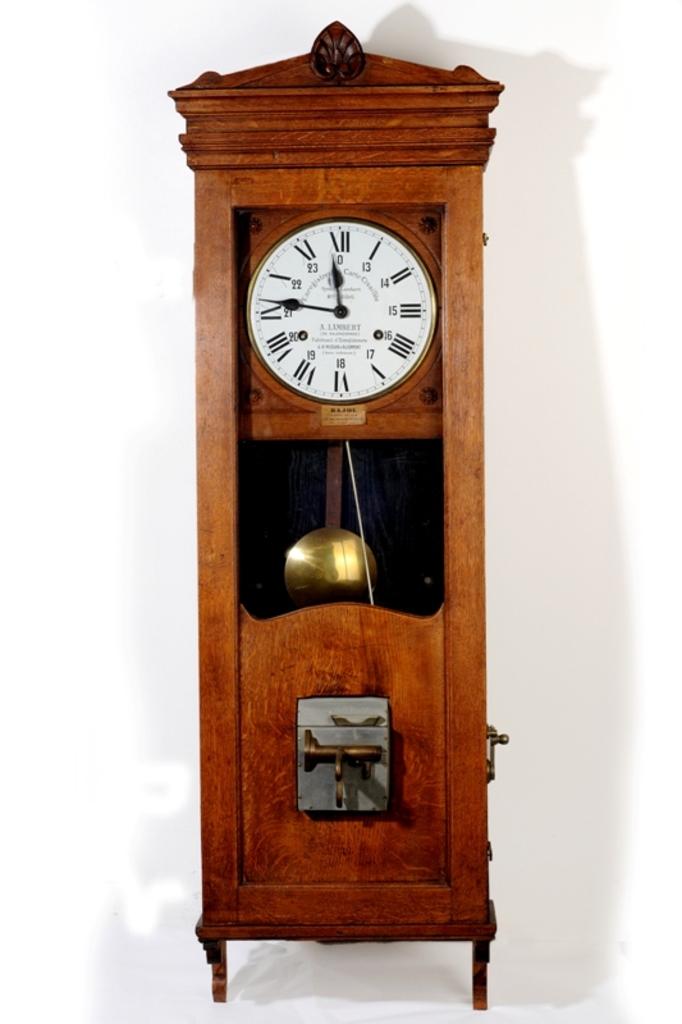What time does the grandfather clock give?
Give a very brief answer. 11:46. What time is on the clock?
Your response must be concise. 11:46. 